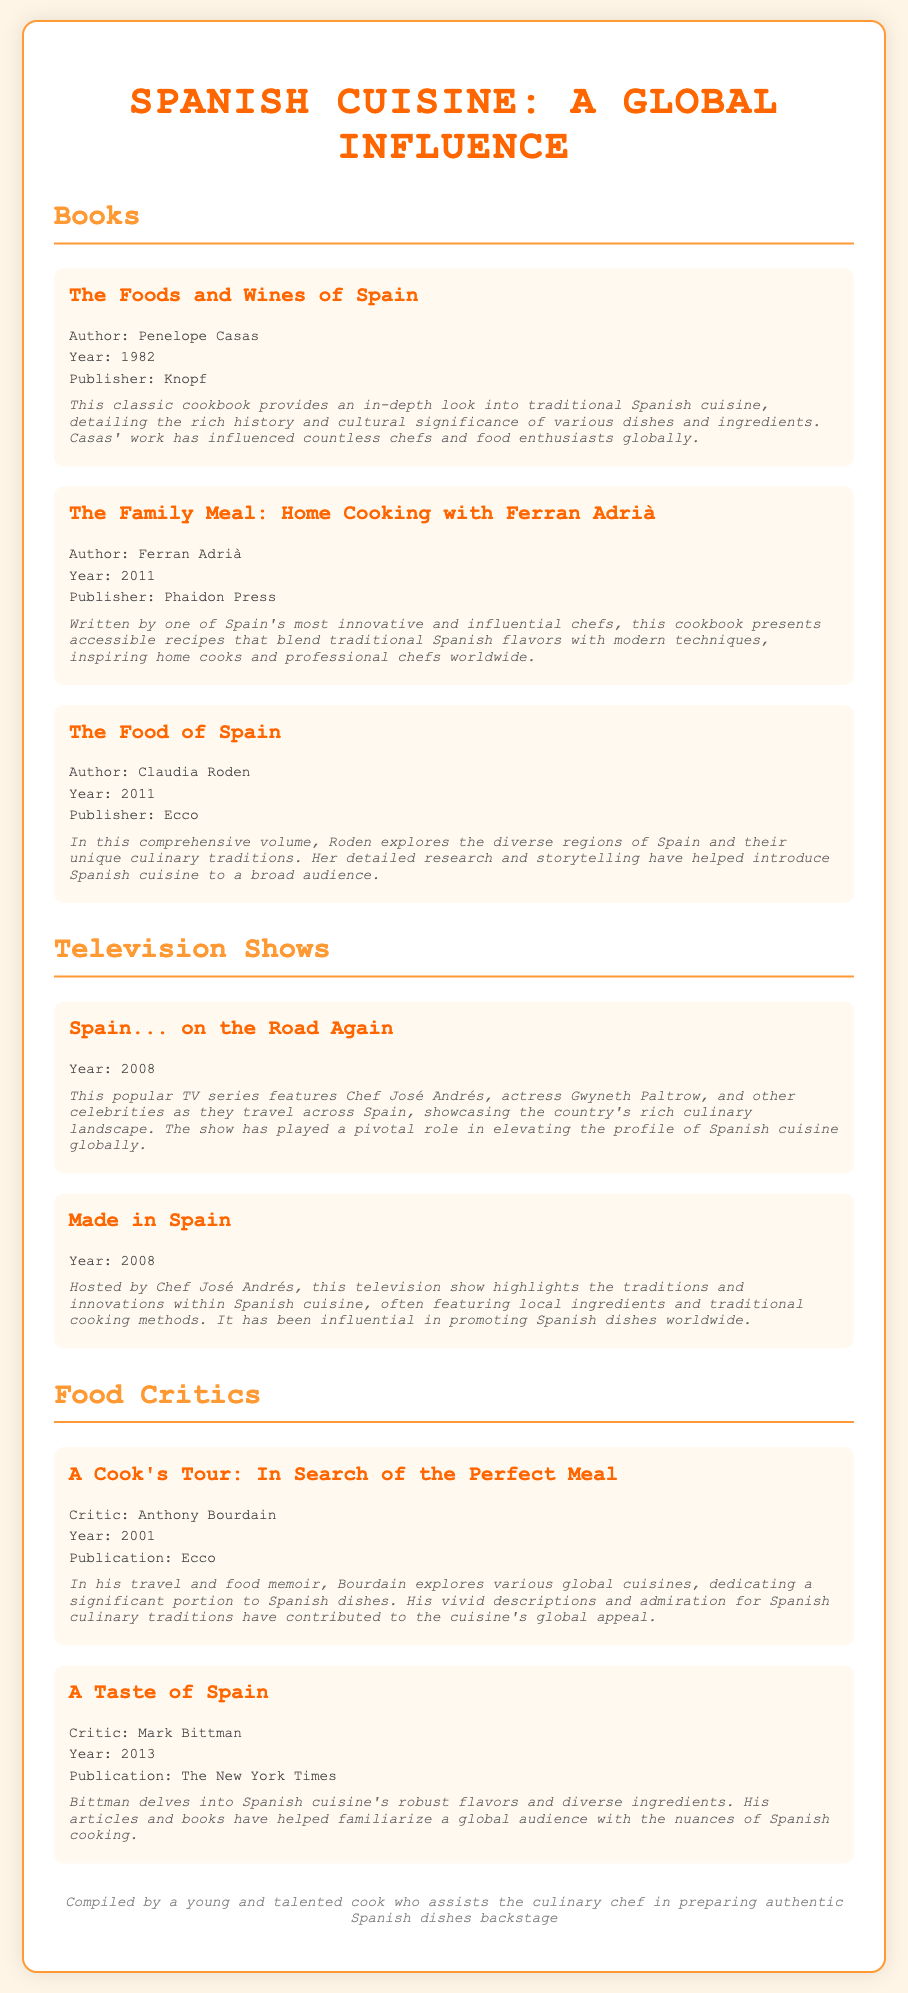what is the title of the first book listed? The first book listed in the bibliography is "The Foods and Wines of Spain."
Answer: The Foods and Wines of Spain who is the author of "The Family Meal: Home Cooking with Ferran Adrià"? The author of this cookbook is Ferran Adrià.
Answer: Ferran Adrià in what year was "The Food of Spain" published? "The Food of Spain" was published in the year 2011.
Answer: 2011 which television show features Chef José Andrés and was released in 2008? The television shows featuring Chef José Andrés released in 2008 are "Spain... on the Road Again" and "Made in Spain."
Answer: Spain... on the Road Again and Made in Spain who wrote the book "A Cook's Tour: In Search of the Perfect Meal"? The author of "A Cook's Tour: In Search of the Perfect Meal" is Anthony Bourdain.
Answer: Anthony Bourdain which food critic wrote about the robust flavors of Spanish cuisine in 2013? Mark Bittman wrote about the robust flavors of Spanish cuisine in 2013.
Answer: Mark Bittman what type of content does "The Foods and Wines of Spain" focus on? The book focuses on traditional Spanish cuisine, its history, and cultural significance.
Answer: Traditional Spanish cuisine how many entries are listed under television shows? There are two entries listed under television shows.
Answer: Two what is a major theme discussed in "The Family Meal: Home Cooking with Ferran Adrià"? The book presents accessible recipes blending traditional Spanish flavors with modern techniques.
Answer: Accessible recipes blending traditional and modern techniques 